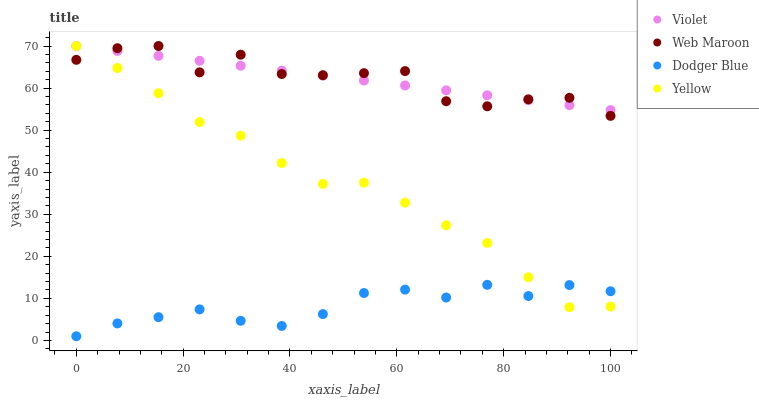Does Dodger Blue have the minimum area under the curve?
Answer yes or no. Yes. Does Web Maroon have the maximum area under the curve?
Answer yes or no. Yes. Does Yellow have the minimum area under the curve?
Answer yes or no. No. Does Yellow have the maximum area under the curve?
Answer yes or no. No. Is Violet the smoothest?
Answer yes or no. Yes. Is Web Maroon the roughest?
Answer yes or no. Yes. Is Yellow the smoothest?
Answer yes or no. No. Is Yellow the roughest?
Answer yes or no. No. Does Dodger Blue have the lowest value?
Answer yes or no. Yes. Does Web Maroon have the lowest value?
Answer yes or no. No. Does Violet have the highest value?
Answer yes or no. Yes. Is Dodger Blue less than Web Maroon?
Answer yes or no. Yes. Is Web Maroon greater than Dodger Blue?
Answer yes or no. Yes. Does Yellow intersect Web Maroon?
Answer yes or no. Yes. Is Yellow less than Web Maroon?
Answer yes or no. No. Is Yellow greater than Web Maroon?
Answer yes or no. No. Does Dodger Blue intersect Web Maroon?
Answer yes or no. No. 